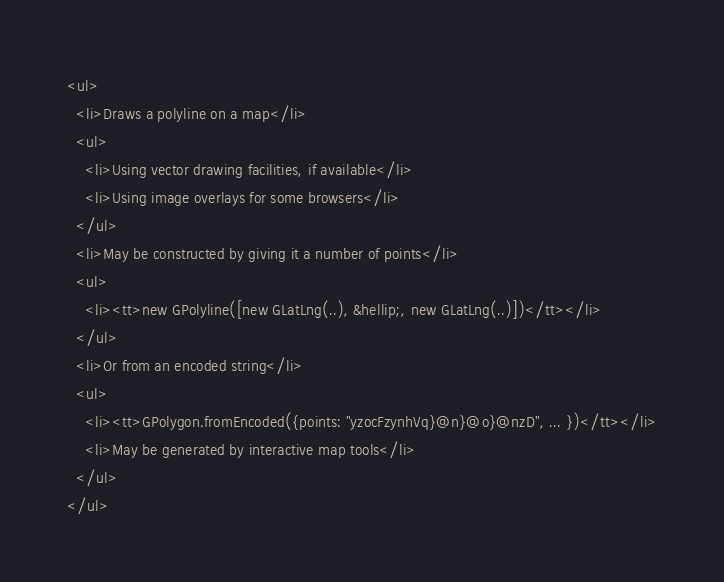<code> <loc_0><loc_0><loc_500><loc_500><_HTML_><ul>
  <li>Draws a polyline on a map</li>
  <ul>
    <li>Using vector drawing facilities, if available</li>
    <li>Using image overlays for some browsers</li>
  </ul>
  <li>May be constructed by giving it a number of points</li>
  <ul>
    <li><tt>new GPolyline([new GLatLng(..), &hellip;, new GLatLng(..)])</tt></li>
  </ul>
  <li>Or from an encoded string</li>
  <ul>
    <li><tt>GPolygon.fromEncoded({points: "yzocFzynhVq}@n}@o}@nzD", ... })</tt></li>
    <li>May be generated by interactive map tools</li>
  </ul>
</ul>
</code> 